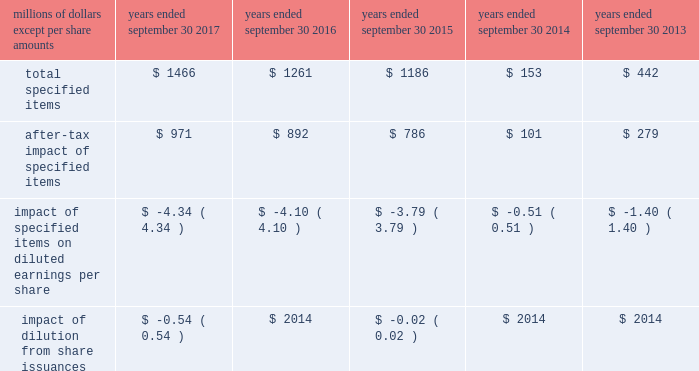( a ) excludes discontinued operations .
( b ) earnings before interest expense and taxes as a percent of average total assets .
( c ) total debt as a percent of the sum of total debt , shareholders 2019 equity and non-current deferred income tax liabilities .
The results above include the impact of the specified items detailed below .
Additional discussion regarding the specified items in fiscal years 2017 , 2016 and 2015 are provided in item 7 .
Management 2019s discussion and analysis of financial condition and results of operations. .
Item 7 .
Management 2019s discussion and analysis of financial condition and results of operations the following commentary should be read in conjunction with the consolidated financial statements and accompanying notes .
Within the tables presented throughout this discussion , certain columns may not add due to the use of rounded numbers for disclosure purposes .
Percentages and earnings per share amounts presented are calculated from the underlying amounts .
References to years throughout this discussion relate to our fiscal years , which end on september 30 .
Company overview description of the company and business segments becton , dickinson and company ( 201cbd 201d ) is a global medical technology company engaged in the development , manufacture and sale of a broad range of medical supplies , devices , laboratory equipment and diagnostic products used by healthcare institutions , life science researchers , clinical laboratories , the pharmaceutical industry and the general public .
The company's organizational structure is based upon two principal business segments , bd medical ( 201cmedical 201d ) and bd life sciences ( 201clife sciences 201d ) .
Bd 2019s products are manufactured and sold worldwide .
Our products are marketed in the united states and internationally through independent distribution channels and directly to end-users by bd and independent sales representatives .
We organize our operations outside the united states as follows : europe ; ema ( which includes the commonwealth of independent states , the middle east and africa ) ; greater asia ( which includes japan and asia pacific ) ; latin america ( which includes mexico , central america , the caribbean , and south america ) ; and canada .
We continue to pursue growth opportunities in emerging markets , which include the following geographic regions : eastern europe , the middle east , africa , latin america and certain countries within asia pacific .
We are primarily focused on certain countries whose healthcare systems are expanding , in particular , china and india .
Strategic objectives bd remains focused on delivering sustainable growth and shareholder value , while making appropriate investments for the future .
Bd management operates the business consistent with the following core strategies : 2022 to increase revenue growth by focusing on our core products , services and solutions that deliver greater benefits to patients , healthcare workers and researchers; .
Based on the management 2019s discussion and analysis of financial condition and results of operations what wa steh approximate tax expense of the total specified items in 2018 in millions? 
Computations: (1466 - 971)
Answer: 495.0. 